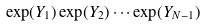<formula> <loc_0><loc_0><loc_500><loc_500>\exp ( Y _ { 1 } ) \exp ( Y _ { 2 } ) \cdots \exp ( Y _ { N - 1 } )</formula> 